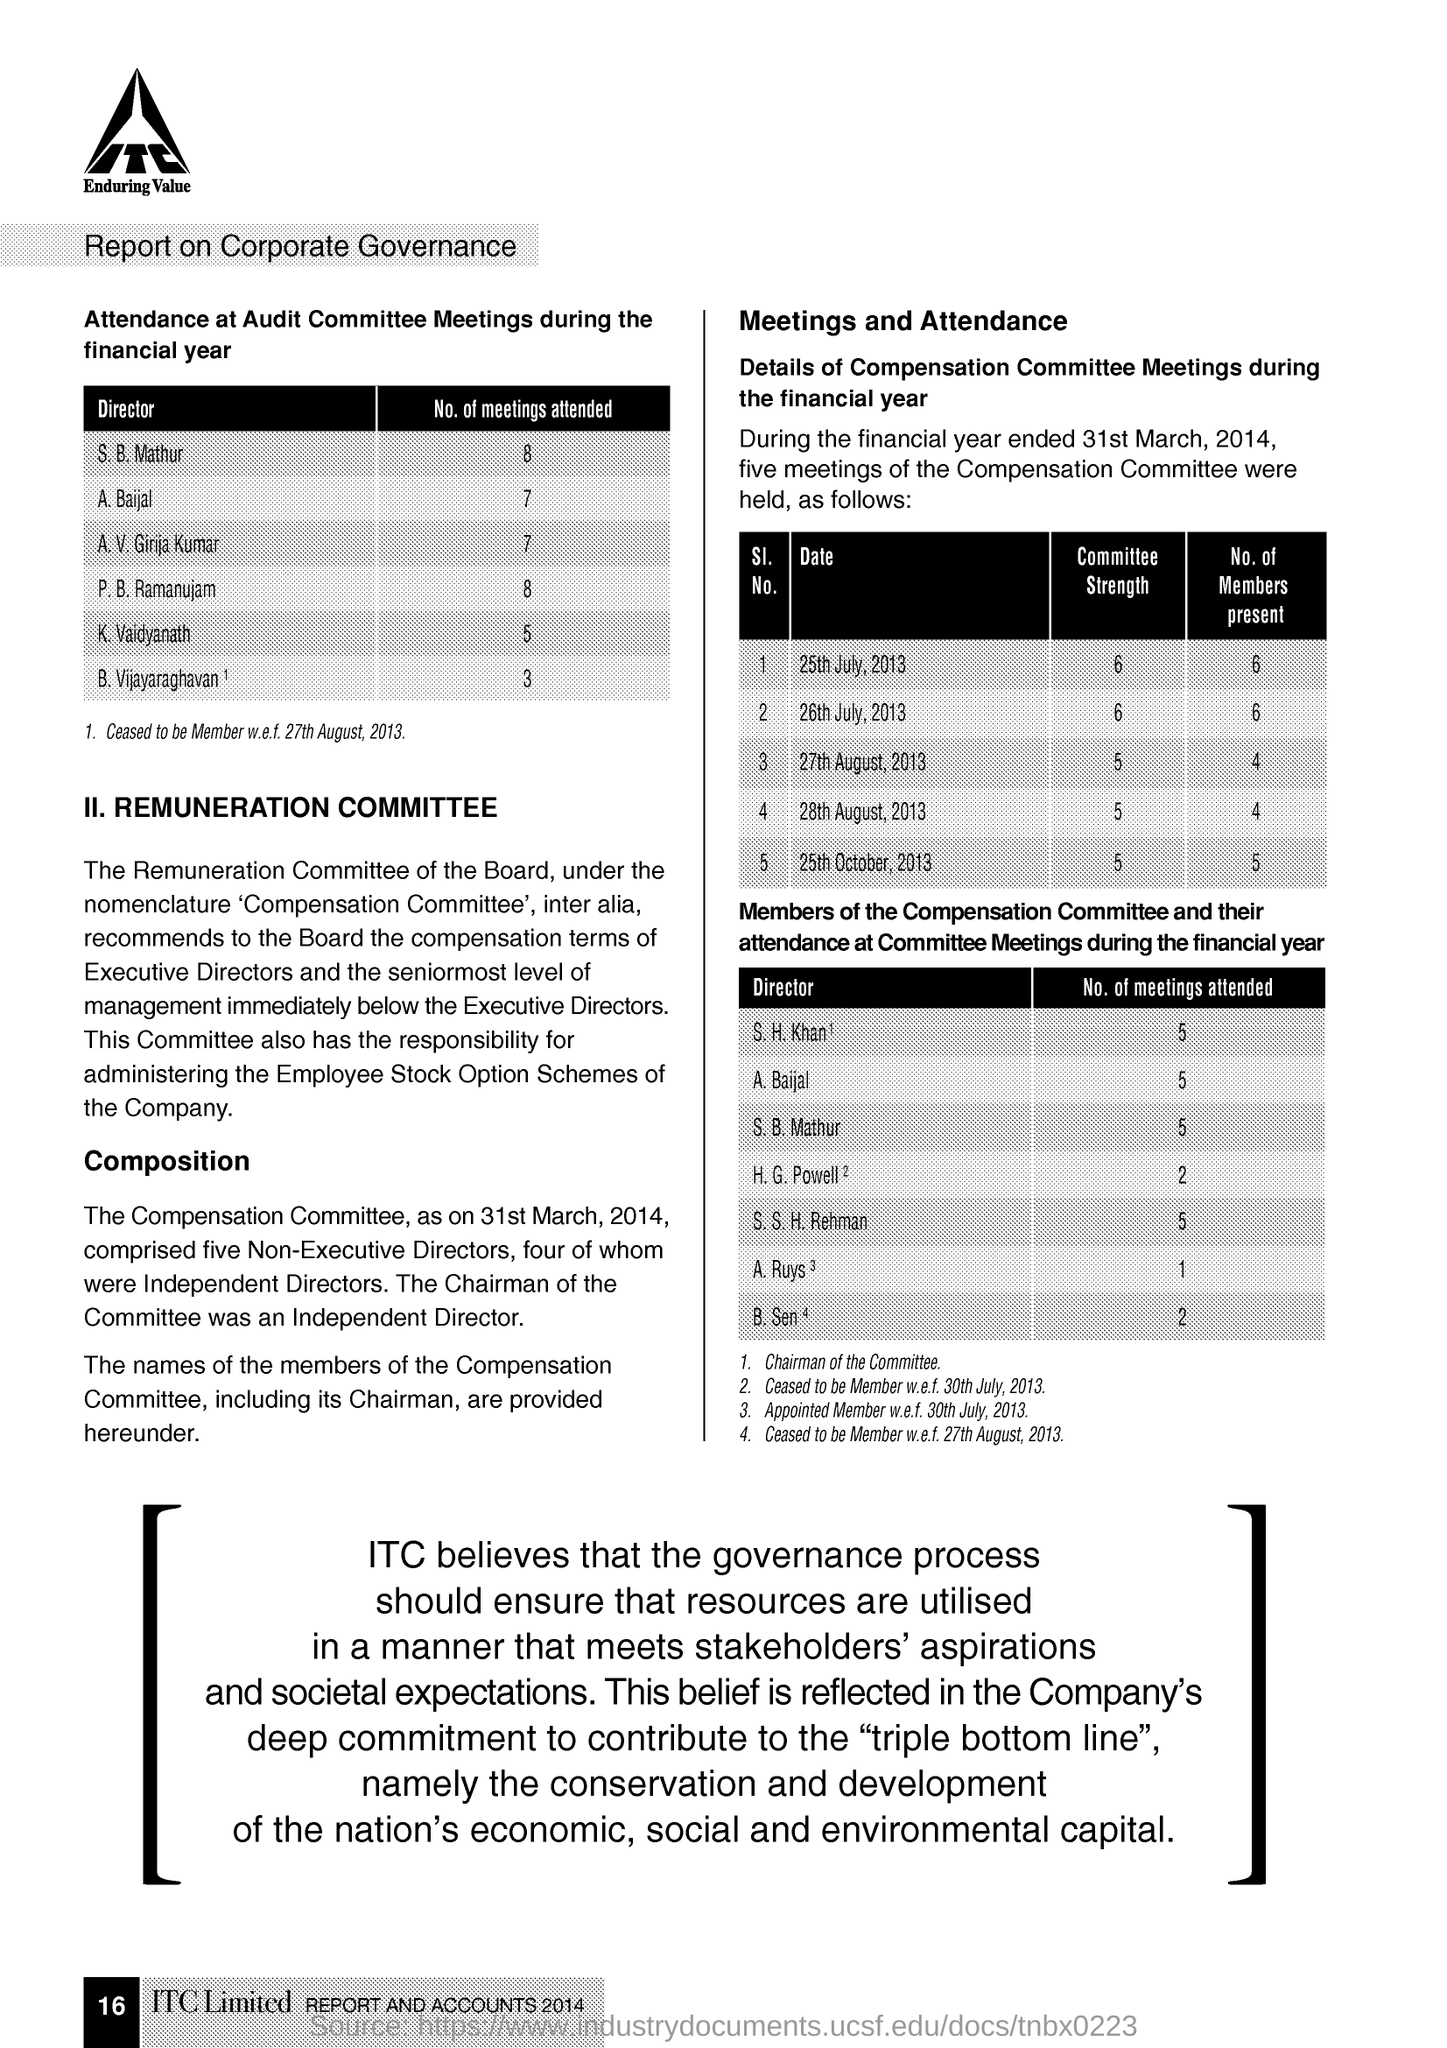Which company is mentioned in the document?
Keep it short and to the point. ITC Limited. 